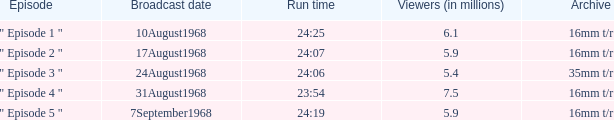How many episodes in history have a running time of 24:06? 1.0. 